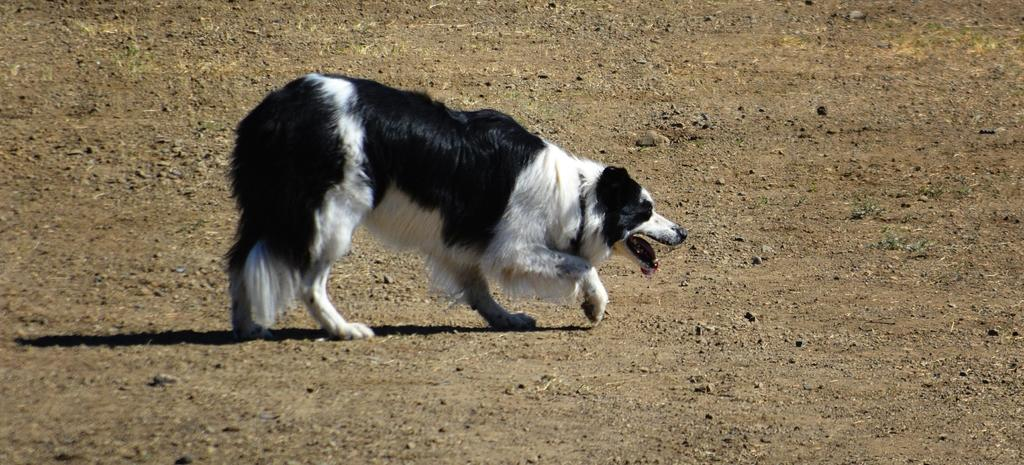What animal is present in the image? There is a dog in the image. What colors can be seen on the dog? The dog is black and white in color. Where is the dog located in the image? The dog is on the ground. What is the color of the ground in the image? The ground is brown in color. Is there a lamp illuminating the dog in the image? There is no lamp present in the image, so it cannot be determined if it is illuminating the dog. 